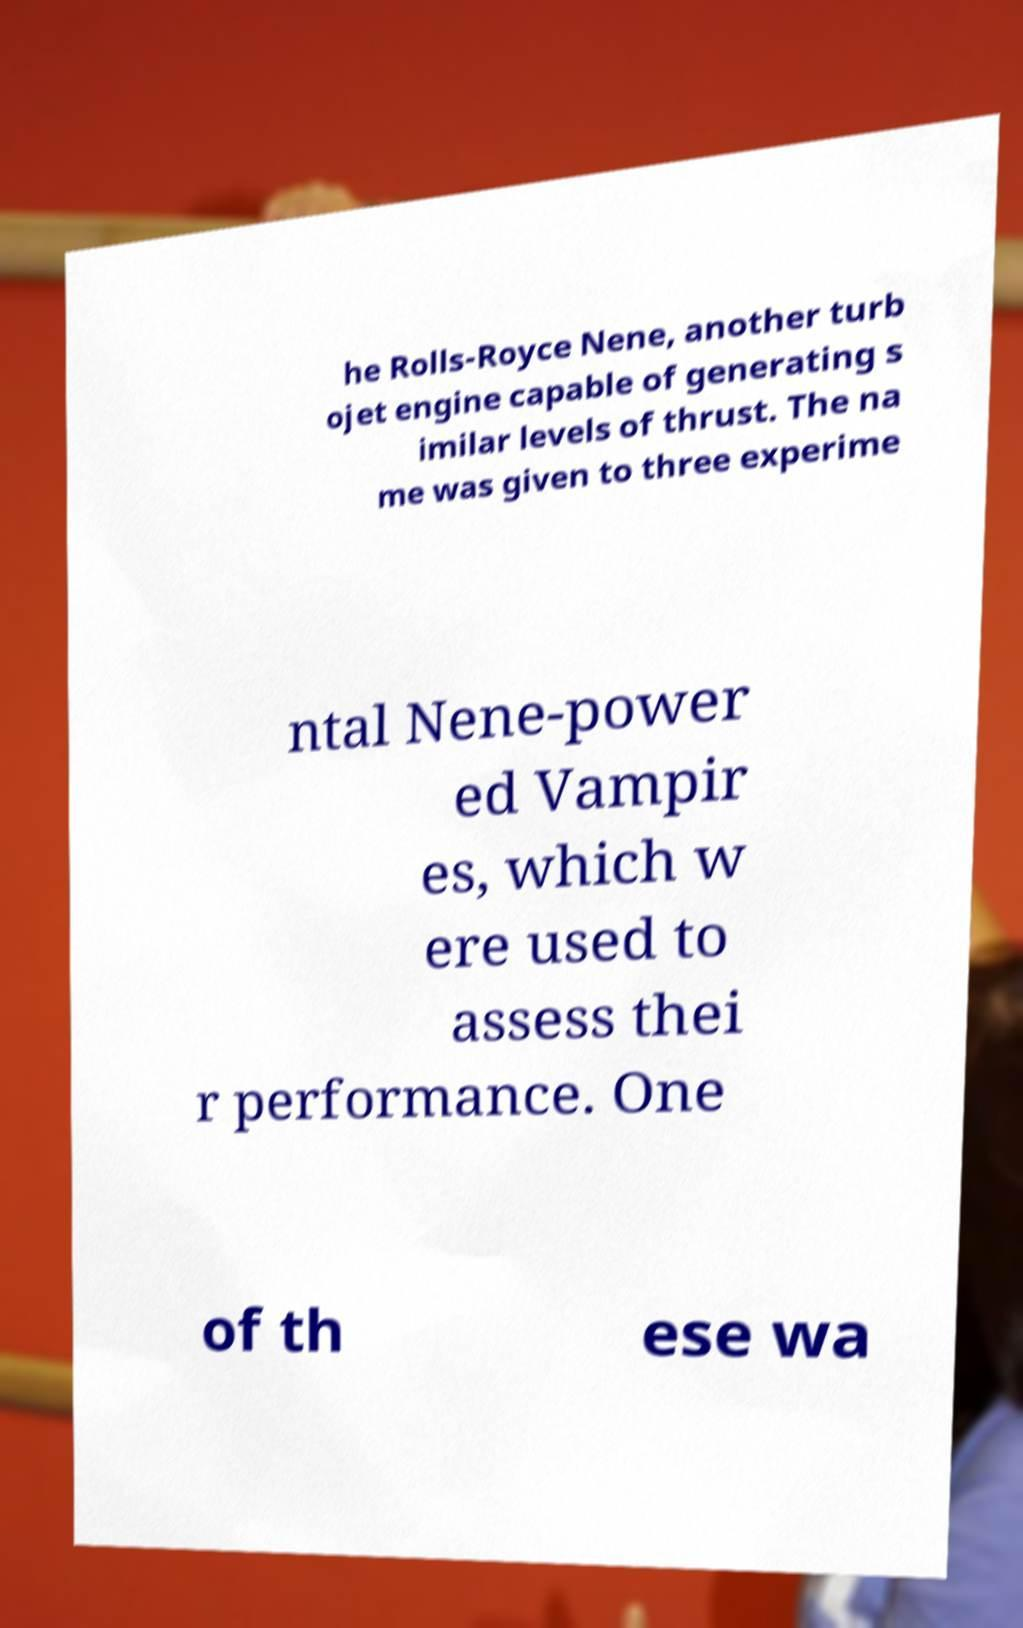Could you extract and type out the text from this image? he Rolls-Royce Nene, another turb ojet engine capable of generating s imilar levels of thrust. The na me was given to three experime ntal Nene-power ed Vampir es, which w ere used to assess thei r performance. One of th ese wa 